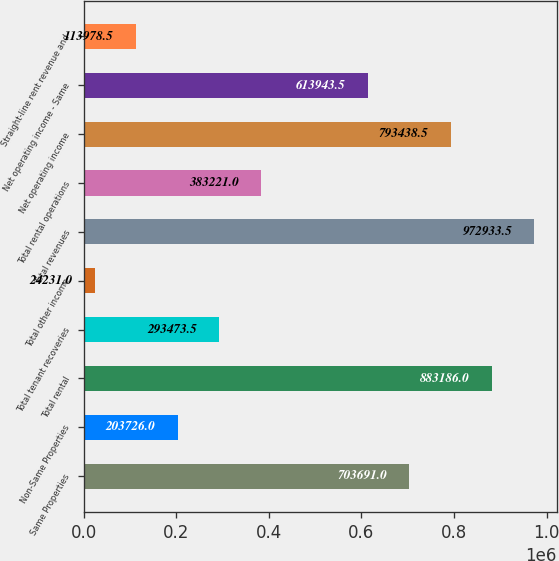<chart> <loc_0><loc_0><loc_500><loc_500><bar_chart><fcel>Same Properties<fcel>Non-Same Properties<fcel>Total rental<fcel>Total tenant recoveries<fcel>Total other income<fcel>Total revenues<fcel>Total rental operations<fcel>Net operating income<fcel>Net operating income - Same<fcel>Straight-line rent revenue and<nl><fcel>703691<fcel>203726<fcel>883186<fcel>293474<fcel>24231<fcel>972934<fcel>383221<fcel>793438<fcel>613944<fcel>113978<nl></chart> 